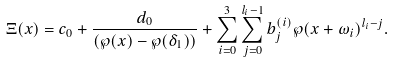<formula> <loc_0><loc_0><loc_500><loc_500>\Xi ( x ) = c _ { 0 } + \frac { d _ { 0 } } { ( \wp ( x ) - \wp ( \delta _ { 1 } ) ) } + \sum _ { i = 0 } ^ { 3 } \sum _ { j = 0 } ^ { l _ { i } - 1 } b ^ { ( i ) } _ { j } \wp ( x + \omega _ { i } ) ^ { l _ { i } - j } .</formula> 